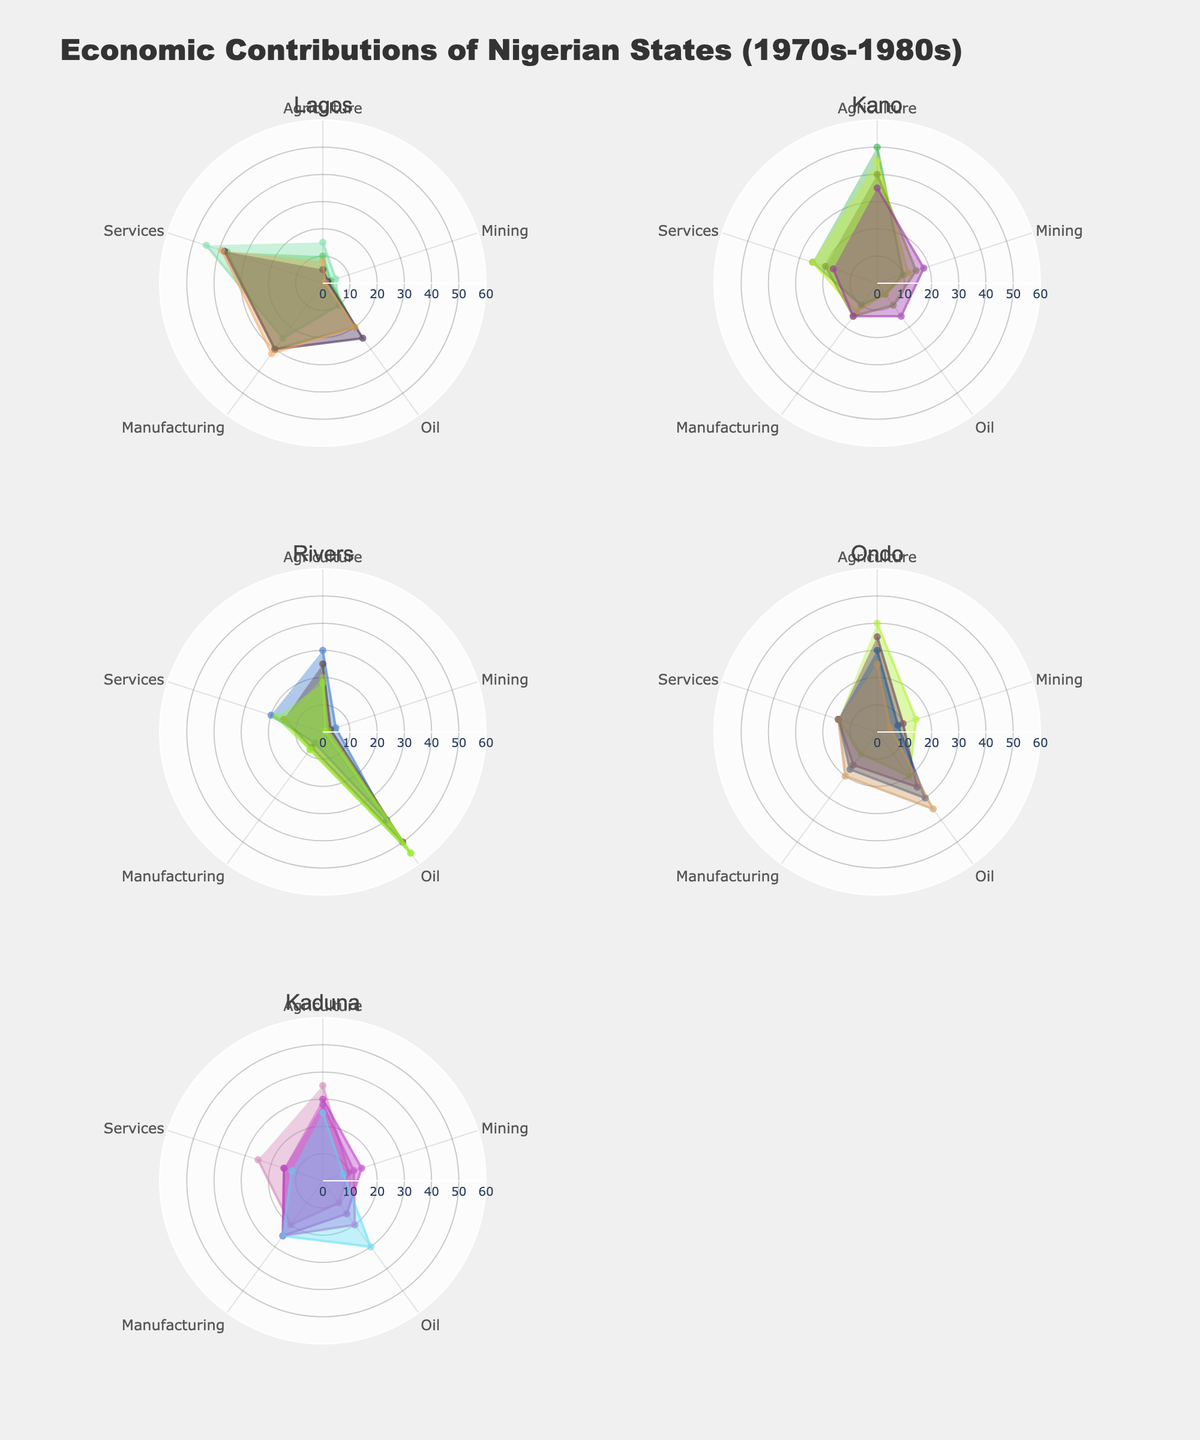Which state had the highest contribution from the Oil sector in 1980? By examining the rose charts for the year 1980 for each state, Rivers had the largest segment for the Oil sector compared to other states.
Answer: Rivers What was the main economic sector for Kano in 1970? By looking at the rose chart for Kano in 1970, the largest sector by visual area is Agriculture.
Answer: Agriculture How did Lagos' contribution from the Services sector change from 1970 to 1985? Comparing the size of the Services segment for Lagos between 1970 and 1985, the percentage increased from 45% to 39%.
Answer: Increased Between Ondo and Kaduna, which state had a higher contribution to Agriculture in 1985? Reviewing the rose charts for 1985, Ondo had a larger segment for Agriculture compared to Kaduna.
Answer: Ondo Which year did Kano witness the highest contribution from Mining? Observing the rose charts across all years for Kano, the segment for Mining was largest in 1985.
Answer: 1985 What was the trend in Lagos' contribution to the Oil sector from 1970 to 1980? Analyzing the rose charts for Lagos from 1970 to 1980, the Oil sector's contribution increased progressively from 10% in 1970 to 25% in 1980.
Answer: Increasing In 1970, which state had the smallest contribution from Manufacturing? Comparing all the rose charts for 1970, Rivers had the smallest segment for Manufacturing.
Answer: Rivers How did the contribution from the Mining sector in Ondo change from 1975 to 1985? By examining the rose charts for Ondo in 1975 and 1985, the Mining sector's contribution decreased from 10% to 5%.
Answer: Decreased Among the given states, which had the most stable contribution from Services from 1970 to 1985? Reviewing the rose charts for all states across the years, Ondo consistently had a 15% contribution from Services.
Answer: Ondo Which sectors showed the most significant decrease in Kano's contribution from 1970 to 1985? By comparing the segments of Kano’s rose charts from 1970 to 1985, Agriculture showed a noticeable decrease from 50% to 35%.
Answer: Agriculture 